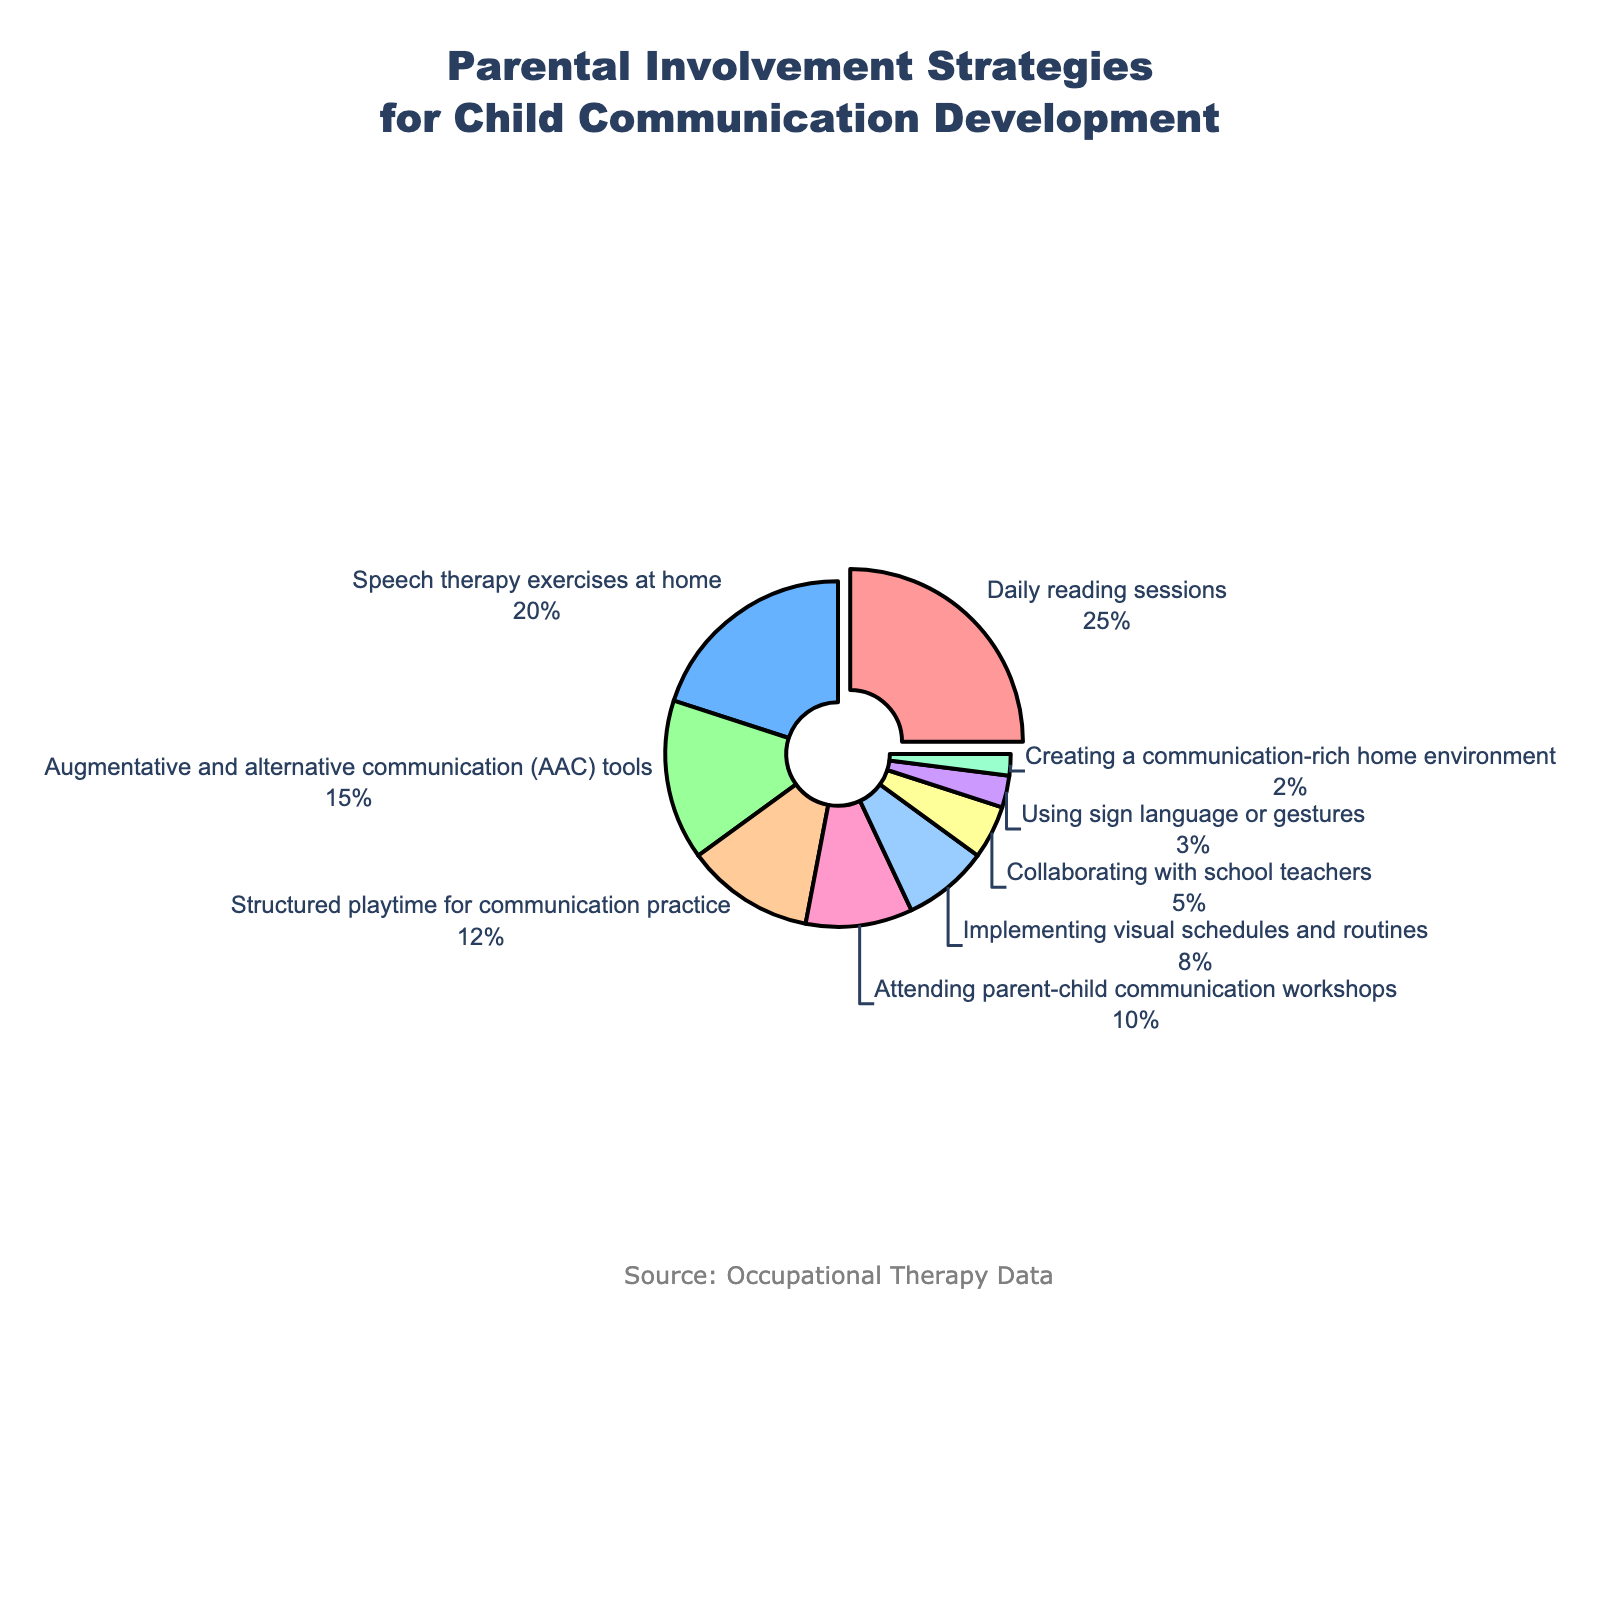What percentage of parental involvement strategies does 'Implementing visual schedules and routines' represent? Look for the segment labeled 'Implementing visual schedules and routines' and identify the percentage next to it.
Answer: 8% Which strategy has the highest percentage, and what is that percentage? Identify the segment with the largest area and look at its label and percentage. The segment pulled out slightly for additional emphasis is 'Daily reading sessions'.
Answer: Daily reading sessions, 25% What is the combined percentage of 'Speech therapy exercises at home' and 'Augmentative and alternative communication (AAC) tools'? Add the percentages of 'Speech therapy exercises at home' (20%) and 'Augmentative and alternative communication (AAC) tools' (15%).
Answer: 35% Which strategy has the smallest percentage and how much is it? Identify the smallest segment in the pie chart and note its label and percentage. The smallest segment is 'Creating a communication-rich home environment'.
Answer: Creating a communication-rich home environment, 2% Compare the percentage of 'Collaborating with school teachers' and 'Using sign language or gestures'. Which one is greater and by how much? 'Collaborating with school teachers' has 5% and 'Using sign language or gestures' has 3%. Subtract 3% from 5%.
Answer: Collaborating with school teachers is greater by 2% How do 'Daily reading sessions' compare to the sum of 'Structured playtime for communication practice' and 'Attending parent-child communication workshops'? 'Daily reading sessions' have 25%. 'Structured playtime for communication practice' and 'Attending parent-child communication workshops' are 12% and 10%, respectively. Their sum is 22%. Compare 25% to 22%.
Answer: Daily reading sessions are greater by 3% What's the total percentage of all activities related to directly practicing communication skills (Daily reading sessions, Speech therapy exercises at home, Structured playtime for communication practice)? Add the percentages of 'Daily reading sessions' (25%), 'Speech therapy exercises at home' (20%), and 'Structured playtime for communication practice' (12%).
Answer: 57% Identify the percentage and color of the segment labeled 'Augmentative and alternative communication (AAC) tools'. Find the segment labeled 'Augmentative and alternative communication (AAC) tools' and note its percentage and color. The percentage is 15%, and the color is a shade of green.
Answer: 15%, green What is the percentage difference between 'Implementing visual schedules and routines' and 'Attending parent-child communication workshops'? 'Implementing visual schedules and routines' is 8% and 'Attending parent-child communication workshops' is 10%. Subtract 8% from 10%.
Answer: 2% 